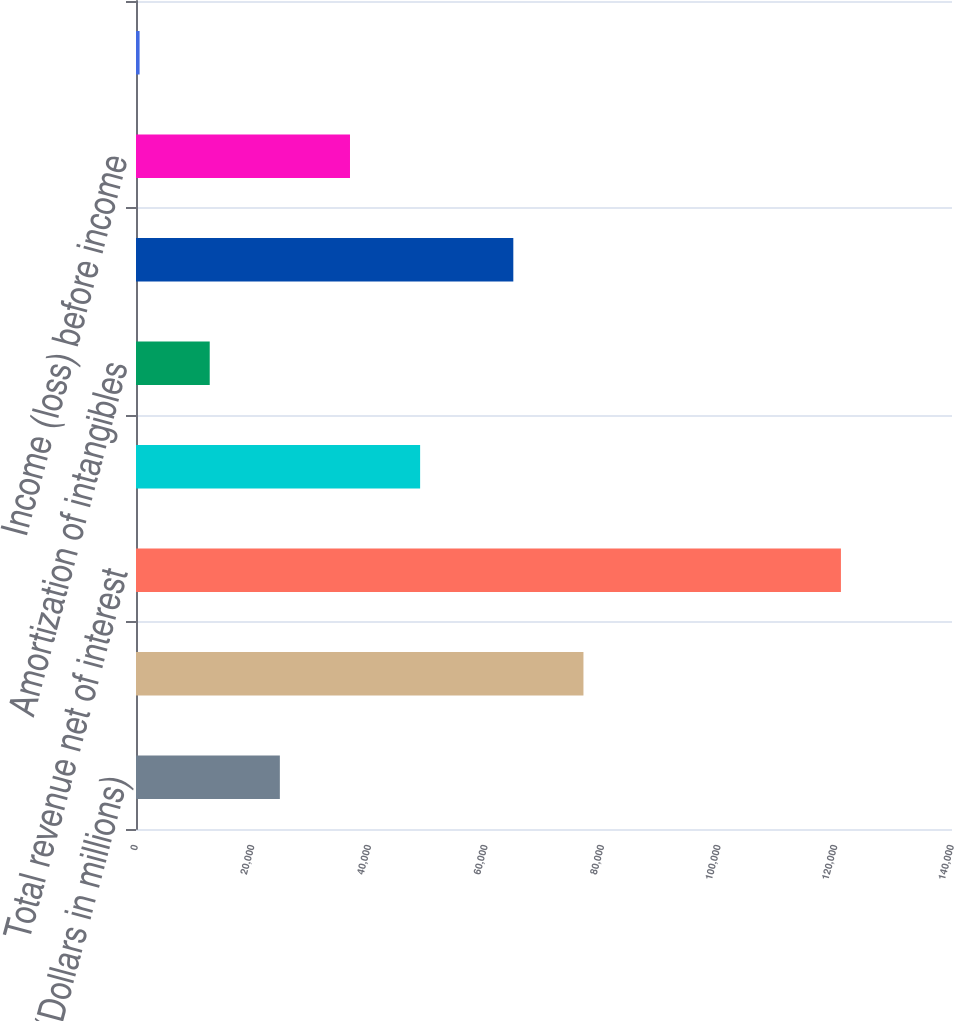Convert chart to OTSL. <chart><loc_0><loc_0><loc_500><loc_500><bar_chart><fcel>(Dollars in millions)<fcel>Noninterest income<fcel>Total revenue net of interest<fcel>Provision for credit losses<fcel>Amortization of intangibles<fcel>Other noninterest expense<fcel>Income (loss) before income<fcel>Income tax expense (benefit)<nl><fcel>24680.8<fcel>76768.9<fcel>120944<fcel>48746.6<fcel>12647.9<fcel>64736<fcel>36713.7<fcel>615<nl></chart> 